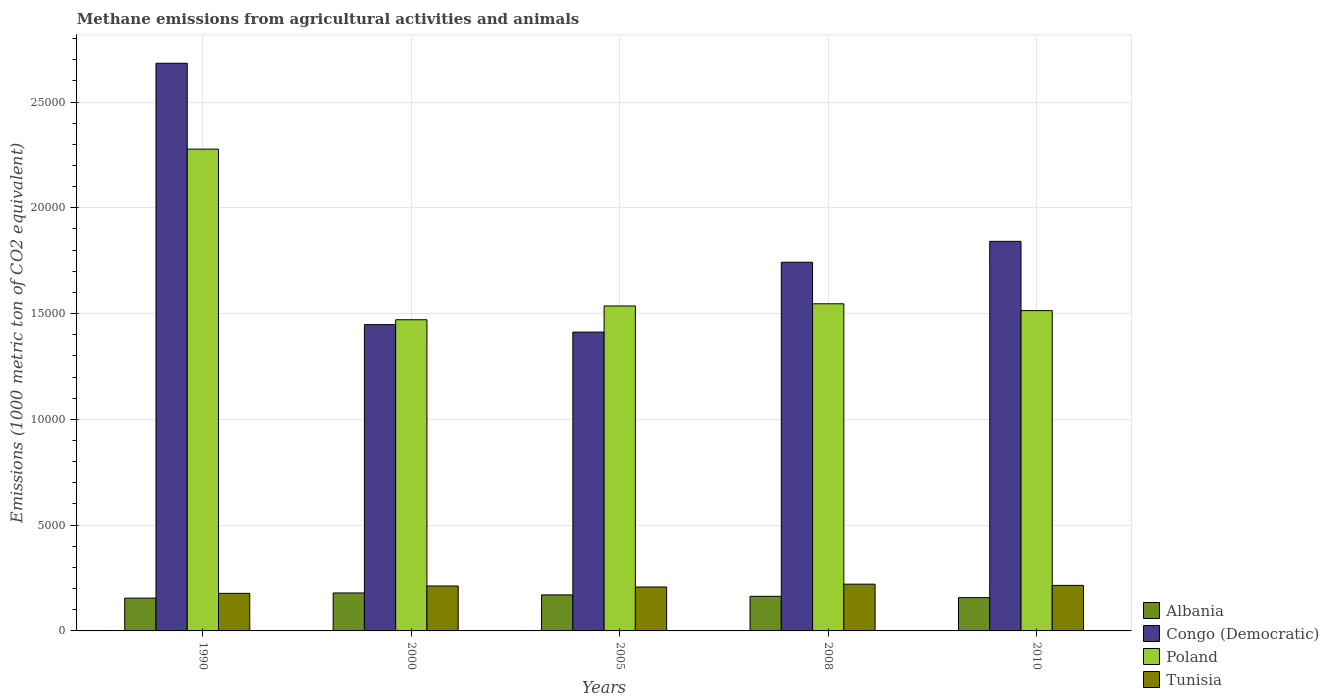How many different coloured bars are there?
Your answer should be very brief. 4. Are the number of bars per tick equal to the number of legend labels?
Your answer should be compact. Yes. Are the number of bars on each tick of the X-axis equal?
Keep it short and to the point. Yes. How many bars are there on the 3rd tick from the left?
Keep it short and to the point. 4. How many bars are there on the 1st tick from the right?
Your response must be concise. 4. In how many cases, is the number of bars for a given year not equal to the number of legend labels?
Keep it short and to the point. 0. What is the amount of methane emitted in Tunisia in 2010?
Your answer should be compact. 2151.9. Across all years, what is the maximum amount of methane emitted in Poland?
Provide a short and direct response. 2.28e+04. Across all years, what is the minimum amount of methane emitted in Tunisia?
Your answer should be very brief. 1775.7. In which year was the amount of methane emitted in Tunisia minimum?
Make the answer very short. 1990. What is the total amount of methane emitted in Poland in the graph?
Offer a very short reply. 8.34e+04. What is the difference between the amount of methane emitted in Albania in 1990 and that in 2000?
Make the answer very short. -243.7. What is the difference between the amount of methane emitted in Congo (Democratic) in 2010 and the amount of methane emitted in Poland in 1990?
Your answer should be very brief. -4358.7. What is the average amount of methane emitted in Poland per year?
Make the answer very short. 1.67e+04. In the year 2000, what is the difference between the amount of methane emitted in Tunisia and amount of methane emitted in Albania?
Your answer should be compact. 329.2. In how many years, is the amount of methane emitted in Tunisia greater than 5000 1000 metric ton?
Your answer should be very brief. 0. What is the ratio of the amount of methane emitted in Tunisia in 2000 to that in 2005?
Your answer should be very brief. 1.02. What is the difference between the highest and the second highest amount of methane emitted in Albania?
Offer a very short reply. 91.7. What is the difference between the highest and the lowest amount of methane emitted in Albania?
Your answer should be very brief. 243.7. Is it the case that in every year, the sum of the amount of methane emitted in Albania and amount of methane emitted in Poland is greater than the sum of amount of methane emitted in Tunisia and amount of methane emitted in Congo (Democratic)?
Make the answer very short. Yes. What does the 4th bar from the right in 2008 represents?
Provide a short and direct response. Albania. How many bars are there?
Ensure brevity in your answer.  20. What is the title of the graph?
Provide a short and direct response. Methane emissions from agricultural activities and animals. What is the label or title of the X-axis?
Ensure brevity in your answer.  Years. What is the label or title of the Y-axis?
Make the answer very short. Emissions (1000 metric ton of CO2 equivalent). What is the Emissions (1000 metric ton of CO2 equivalent) in Albania in 1990?
Ensure brevity in your answer.  1550.9. What is the Emissions (1000 metric ton of CO2 equivalent) in Congo (Democratic) in 1990?
Give a very brief answer. 2.68e+04. What is the Emissions (1000 metric ton of CO2 equivalent) in Poland in 1990?
Make the answer very short. 2.28e+04. What is the Emissions (1000 metric ton of CO2 equivalent) of Tunisia in 1990?
Your response must be concise. 1775.7. What is the Emissions (1000 metric ton of CO2 equivalent) of Albania in 2000?
Ensure brevity in your answer.  1794.6. What is the Emissions (1000 metric ton of CO2 equivalent) of Congo (Democratic) in 2000?
Keep it short and to the point. 1.45e+04. What is the Emissions (1000 metric ton of CO2 equivalent) of Poland in 2000?
Offer a very short reply. 1.47e+04. What is the Emissions (1000 metric ton of CO2 equivalent) in Tunisia in 2000?
Offer a very short reply. 2123.8. What is the Emissions (1000 metric ton of CO2 equivalent) in Albania in 2005?
Keep it short and to the point. 1702.9. What is the Emissions (1000 metric ton of CO2 equivalent) in Congo (Democratic) in 2005?
Make the answer very short. 1.41e+04. What is the Emissions (1000 metric ton of CO2 equivalent) of Poland in 2005?
Offer a terse response. 1.54e+04. What is the Emissions (1000 metric ton of CO2 equivalent) of Tunisia in 2005?
Provide a short and direct response. 2076.8. What is the Emissions (1000 metric ton of CO2 equivalent) in Albania in 2008?
Provide a succinct answer. 1635.8. What is the Emissions (1000 metric ton of CO2 equivalent) of Congo (Democratic) in 2008?
Your answer should be compact. 1.74e+04. What is the Emissions (1000 metric ton of CO2 equivalent) in Poland in 2008?
Your answer should be very brief. 1.55e+04. What is the Emissions (1000 metric ton of CO2 equivalent) of Tunisia in 2008?
Offer a terse response. 2209.8. What is the Emissions (1000 metric ton of CO2 equivalent) in Albania in 2010?
Make the answer very short. 1574.1. What is the Emissions (1000 metric ton of CO2 equivalent) of Congo (Democratic) in 2010?
Your response must be concise. 1.84e+04. What is the Emissions (1000 metric ton of CO2 equivalent) of Poland in 2010?
Your response must be concise. 1.51e+04. What is the Emissions (1000 metric ton of CO2 equivalent) in Tunisia in 2010?
Offer a terse response. 2151.9. Across all years, what is the maximum Emissions (1000 metric ton of CO2 equivalent) of Albania?
Your answer should be compact. 1794.6. Across all years, what is the maximum Emissions (1000 metric ton of CO2 equivalent) in Congo (Democratic)?
Offer a very short reply. 2.68e+04. Across all years, what is the maximum Emissions (1000 metric ton of CO2 equivalent) in Poland?
Keep it short and to the point. 2.28e+04. Across all years, what is the maximum Emissions (1000 metric ton of CO2 equivalent) in Tunisia?
Keep it short and to the point. 2209.8. Across all years, what is the minimum Emissions (1000 metric ton of CO2 equivalent) in Albania?
Give a very brief answer. 1550.9. Across all years, what is the minimum Emissions (1000 metric ton of CO2 equivalent) in Congo (Democratic)?
Make the answer very short. 1.41e+04. Across all years, what is the minimum Emissions (1000 metric ton of CO2 equivalent) in Poland?
Provide a short and direct response. 1.47e+04. Across all years, what is the minimum Emissions (1000 metric ton of CO2 equivalent) of Tunisia?
Your answer should be compact. 1775.7. What is the total Emissions (1000 metric ton of CO2 equivalent) in Albania in the graph?
Your answer should be compact. 8258.3. What is the total Emissions (1000 metric ton of CO2 equivalent) of Congo (Democratic) in the graph?
Give a very brief answer. 9.13e+04. What is the total Emissions (1000 metric ton of CO2 equivalent) of Poland in the graph?
Provide a short and direct response. 8.34e+04. What is the total Emissions (1000 metric ton of CO2 equivalent) in Tunisia in the graph?
Your response must be concise. 1.03e+04. What is the difference between the Emissions (1000 metric ton of CO2 equivalent) of Albania in 1990 and that in 2000?
Make the answer very short. -243.7. What is the difference between the Emissions (1000 metric ton of CO2 equivalent) of Congo (Democratic) in 1990 and that in 2000?
Provide a succinct answer. 1.24e+04. What is the difference between the Emissions (1000 metric ton of CO2 equivalent) of Poland in 1990 and that in 2000?
Give a very brief answer. 8065. What is the difference between the Emissions (1000 metric ton of CO2 equivalent) in Tunisia in 1990 and that in 2000?
Provide a short and direct response. -348.1. What is the difference between the Emissions (1000 metric ton of CO2 equivalent) in Albania in 1990 and that in 2005?
Your answer should be compact. -152. What is the difference between the Emissions (1000 metric ton of CO2 equivalent) of Congo (Democratic) in 1990 and that in 2005?
Keep it short and to the point. 1.27e+04. What is the difference between the Emissions (1000 metric ton of CO2 equivalent) of Poland in 1990 and that in 2005?
Provide a short and direct response. 7413.7. What is the difference between the Emissions (1000 metric ton of CO2 equivalent) in Tunisia in 1990 and that in 2005?
Make the answer very short. -301.1. What is the difference between the Emissions (1000 metric ton of CO2 equivalent) in Albania in 1990 and that in 2008?
Keep it short and to the point. -84.9. What is the difference between the Emissions (1000 metric ton of CO2 equivalent) in Congo (Democratic) in 1990 and that in 2008?
Offer a very short reply. 9404.9. What is the difference between the Emissions (1000 metric ton of CO2 equivalent) in Poland in 1990 and that in 2008?
Keep it short and to the point. 7311.1. What is the difference between the Emissions (1000 metric ton of CO2 equivalent) in Tunisia in 1990 and that in 2008?
Offer a terse response. -434.1. What is the difference between the Emissions (1000 metric ton of CO2 equivalent) in Albania in 1990 and that in 2010?
Your response must be concise. -23.2. What is the difference between the Emissions (1000 metric ton of CO2 equivalent) in Congo (Democratic) in 1990 and that in 2010?
Your answer should be very brief. 8416.9. What is the difference between the Emissions (1000 metric ton of CO2 equivalent) in Poland in 1990 and that in 2010?
Provide a succinct answer. 7634.1. What is the difference between the Emissions (1000 metric ton of CO2 equivalent) in Tunisia in 1990 and that in 2010?
Your answer should be compact. -376.2. What is the difference between the Emissions (1000 metric ton of CO2 equivalent) in Albania in 2000 and that in 2005?
Make the answer very short. 91.7. What is the difference between the Emissions (1000 metric ton of CO2 equivalent) in Congo (Democratic) in 2000 and that in 2005?
Your response must be concise. 352. What is the difference between the Emissions (1000 metric ton of CO2 equivalent) in Poland in 2000 and that in 2005?
Give a very brief answer. -651.3. What is the difference between the Emissions (1000 metric ton of CO2 equivalent) of Albania in 2000 and that in 2008?
Provide a short and direct response. 158.8. What is the difference between the Emissions (1000 metric ton of CO2 equivalent) of Congo (Democratic) in 2000 and that in 2008?
Your response must be concise. -2949. What is the difference between the Emissions (1000 metric ton of CO2 equivalent) in Poland in 2000 and that in 2008?
Keep it short and to the point. -753.9. What is the difference between the Emissions (1000 metric ton of CO2 equivalent) in Tunisia in 2000 and that in 2008?
Provide a succinct answer. -86. What is the difference between the Emissions (1000 metric ton of CO2 equivalent) of Albania in 2000 and that in 2010?
Your answer should be very brief. 220.5. What is the difference between the Emissions (1000 metric ton of CO2 equivalent) of Congo (Democratic) in 2000 and that in 2010?
Offer a terse response. -3937. What is the difference between the Emissions (1000 metric ton of CO2 equivalent) in Poland in 2000 and that in 2010?
Make the answer very short. -430.9. What is the difference between the Emissions (1000 metric ton of CO2 equivalent) of Tunisia in 2000 and that in 2010?
Provide a succinct answer. -28.1. What is the difference between the Emissions (1000 metric ton of CO2 equivalent) in Albania in 2005 and that in 2008?
Provide a succinct answer. 67.1. What is the difference between the Emissions (1000 metric ton of CO2 equivalent) of Congo (Democratic) in 2005 and that in 2008?
Provide a succinct answer. -3301. What is the difference between the Emissions (1000 metric ton of CO2 equivalent) of Poland in 2005 and that in 2008?
Offer a very short reply. -102.6. What is the difference between the Emissions (1000 metric ton of CO2 equivalent) in Tunisia in 2005 and that in 2008?
Provide a short and direct response. -133. What is the difference between the Emissions (1000 metric ton of CO2 equivalent) of Albania in 2005 and that in 2010?
Your answer should be very brief. 128.8. What is the difference between the Emissions (1000 metric ton of CO2 equivalent) of Congo (Democratic) in 2005 and that in 2010?
Make the answer very short. -4289. What is the difference between the Emissions (1000 metric ton of CO2 equivalent) of Poland in 2005 and that in 2010?
Your answer should be compact. 220.4. What is the difference between the Emissions (1000 metric ton of CO2 equivalent) in Tunisia in 2005 and that in 2010?
Your answer should be compact. -75.1. What is the difference between the Emissions (1000 metric ton of CO2 equivalent) of Albania in 2008 and that in 2010?
Offer a terse response. 61.7. What is the difference between the Emissions (1000 metric ton of CO2 equivalent) of Congo (Democratic) in 2008 and that in 2010?
Ensure brevity in your answer.  -988. What is the difference between the Emissions (1000 metric ton of CO2 equivalent) in Poland in 2008 and that in 2010?
Offer a terse response. 323. What is the difference between the Emissions (1000 metric ton of CO2 equivalent) of Tunisia in 2008 and that in 2010?
Your response must be concise. 57.9. What is the difference between the Emissions (1000 metric ton of CO2 equivalent) in Albania in 1990 and the Emissions (1000 metric ton of CO2 equivalent) in Congo (Democratic) in 2000?
Offer a terse response. -1.29e+04. What is the difference between the Emissions (1000 metric ton of CO2 equivalent) of Albania in 1990 and the Emissions (1000 metric ton of CO2 equivalent) of Poland in 2000?
Keep it short and to the point. -1.32e+04. What is the difference between the Emissions (1000 metric ton of CO2 equivalent) of Albania in 1990 and the Emissions (1000 metric ton of CO2 equivalent) of Tunisia in 2000?
Offer a terse response. -572.9. What is the difference between the Emissions (1000 metric ton of CO2 equivalent) in Congo (Democratic) in 1990 and the Emissions (1000 metric ton of CO2 equivalent) in Poland in 2000?
Your answer should be compact. 1.21e+04. What is the difference between the Emissions (1000 metric ton of CO2 equivalent) of Congo (Democratic) in 1990 and the Emissions (1000 metric ton of CO2 equivalent) of Tunisia in 2000?
Your answer should be compact. 2.47e+04. What is the difference between the Emissions (1000 metric ton of CO2 equivalent) of Poland in 1990 and the Emissions (1000 metric ton of CO2 equivalent) of Tunisia in 2000?
Give a very brief answer. 2.06e+04. What is the difference between the Emissions (1000 metric ton of CO2 equivalent) in Albania in 1990 and the Emissions (1000 metric ton of CO2 equivalent) in Congo (Democratic) in 2005?
Give a very brief answer. -1.26e+04. What is the difference between the Emissions (1000 metric ton of CO2 equivalent) of Albania in 1990 and the Emissions (1000 metric ton of CO2 equivalent) of Poland in 2005?
Ensure brevity in your answer.  -1.38e+04. What is the difference between the Emissions (1000 metric ton of CO2 equivalent) in Albania in 1990 and the Emissions (1000 metric ton of CO2 equivalent) in Tunisia in 2005?
Provide a succinct answer. -525.9. What is the difference between the Emissions (1000 metric ton of CO2 equivalent) of Congo (Democratic) in 1990 and the Emissions (1000 metric ton of CO2 equivalent) of Poland in 2005?
Your answer should be compact. 1.15e+04. What is the difference between the Emissions (1000 metric ton of CO2 equivalent) of Congo (Democratic) in 1990 and the Emissions (1000 metric ton of CO2 equivalent) of Tunisia in 2005?
Offer a very short reply. 2.48e+04. What is the difference between the Emissions (1000 metric ton of CO2 equivalent) of Poland in 1990 and the Emissions (1000 metric ton of CO2 equivalent) of Tunisia in 2005?
Your answer should be very brief. 2.07e+04. What is the difference between the Emissions (1000 metric ton of CO2 equivalent) of Albania in 1990 and the Emissions (1000 metric ton of CO2 equivalent) of Congo (Democratic) in 2008?
Provide a short and direct response. -1.59e+04. What is the difference between the Emissions (1000 metric ton of CO2 equivalent) of Albania in 1990 and the Emissions (1000 metric ton of CO2 equivalent) of Poland in 2008?
Offer a terse response. -1.39e+04. What is the difference between the Emissions (1000 metric ton of CO2 equivalent) in Albania in 1990 and the Emissions (1000 metric ton of CO2 equivalent) in Tunisia in 2008?
Your answer should be very brief. -658.9. What is the difference between the Emissions (1000 metric ton of CO2 equivalent) in Congo (Democratic) in 1990 and the Emissions (1000 metric ton of CO2 equivalent) in Poland in 2008?
Your response must be concise. 1.14e+04. What is the difference between the Emissions (1000 metric ton of CO2 equivalent) in Congo (Democratic) in 1990 and the Emissions (1000 metric ton of CO2 equivalent) in Tunisia in 2008?
Offer a very short reply. 2.46e+04. What is the difference between the Emissions (1000 metric ton of CO2 equivalent) of Poland in 1990 and the Emissions (1000 metric ton of CO2 equivalent) of Tunisia in 2008?
Provide a short and direct response. 2.06e+04. What is the difference between the Emissions (1000 metric ton of CO2 equivalent) in Albania in 1990 and the Emissions (1000 metric ton of CO2 equivalent) in Congo (Democratic) in 2010?
Make the answer very short. -1.69e+04. What is the difference between the Emissions (1000 metric ton of CO2 equivalent) in Albania in 1990 and the Emissions (1000 metric ton of CO2 equivalent) in Poland in 2010?
Your response must be concise. -1.36e+04. What is the difference between the Emissions (1000 metric ton of CO2 equivalent) of Albania in 1990 and the Emissions (1000 metric ton of CO2 equivalent) of Tunisia in 2010?
Your answer should be very brief. -601. What is the difference between the Emissions (1000 metric ton of CO2 equivalent) in Congo (Democratic) in 1990 and the Emissions (1000 metric ton of CO2 equivalent) in Poland in 2010?
Give a very brief answer. 1.17e+04. What is the difference between the Emissions (1000 metric ton of CO2 equivalent) of Congo (Democratic) in 1990 and the Emissions (1000 metric ton of CO2 equivalent) of Tunisia in 2010?
Ensure brevity in your answer.  2.47e+04. What is the difference between the Emissions (1000 metric ton of CO2 equivalent) in Poland in 1990 and the Emissions (1000 metric ton of CO2 equivalent) in Tunisia in 2010?
Offer a terse response. 2.06e+04. What is the difference between the Emissions (1000 metric ton of CO2 equivalent) of Albania in 2000 and the Emissions (1000 metric ton of CO2 equivalent) of Congo (Democratic) in 2005?
Your answer should be compact. -1.23e+04. What is the difference between the Emissions (1000 metric ton of CO2 equivalent) of Albania in 2000 and the Emissions (1000 metric ton of CO2 equivalent) of Poland in 2005?
Ensure brevity in your answer.  -1.36e+04. What is the difference between the Emissions (1000 metric ton of CO2 equivalent) of Albania in 2000 and the Emissions (1000 metric ton of CO2 equivalent) of Tunisia in 2005?
Give a very brief answer. -282.2. What is the difference between the Emissions (1000 metric ton of CO2 equivalent) of Congo (Democratic) in 2000 and the Emissions (1000 metric ton of CO2 equivalent) of Poland in 2005?
Give a very brief answer. -882. What is the difference between the Emissions (1000 metric ton of CO2 equivalent) in Congo (Democratic) in 2000 and the Emissions (1000 metric ton of CO2 equivalent) in Tunisia in 2005?
Offer a very short reply. 1.24e+04. What is the difference between the Emissions (1000 metric ton of CO2 equivalent) in Poland in 2000 and the Emissions (1000 metric ton of CO2 equivalent) in Tunisia in 2005?
Offer a terse response. 1.26e+04. What is the difference between the Emissions (1000 metric ton of CO2 equivalent) of Albania in 2000 and the Emissions (1000 metric ton of CO2 equivalent) of Congo (Democratic) in 2008?
Provide a short and direct response. -1.56e+04. What is the difference between the Emissions (1000 metric ton of CO2 equivalent) of Albania in 2000 and the Emissions (1000 metric ton of CO2 equivalent) of Poland in 2008?
Make the answer very short. -1.37e+04. What is the difference between the Emissions (1000 metric ton of CO2 equivalent) in Albania in 2000 and the Emissions (1000 metric ton of CO2 equivalent) in Tunisia in 2008?
Make the answer very short. -415.2. What is the difference between the Emissions (1000 metric ton of CO2 equivalent) of Congo (Democratic) in 2000 and the Emissions (1000 metric ton of CO2 equivalent) of Poland in 2008?
Give a very brief answer. -984.6. What is the difference between the Emissions (1000 metric ton of CO2 equivalent) in Congo (Democratic) in 2000 and the Emissions (1000 metric ton of CO2 equivalent) in Tunisia in 2008?
Offer a very short reply. 1.23e+04. What is the difference between the Emissions (1000 metric ton of CO2 equivalent) in Poland in 2000 and the Emissions (1000 metric ton of CO2 equivalent) in Tunisia in 2008?
Make the answer very short. 1.25e+04. What is the difference between the Emissions (1000 metric ton of CO2 equivalent) in Albania in 2000 and the Emissions (1000 metric ton of CO2 equivalent) in Congo (Democratic) in 2010?
Give a very brief answer. -1.66e+04. What is the difference between the Emissions (1000 metric ton of CO2 equivalent) of Albania in 2000 and the Emissions (1000 metric ton of CO2 equivalent) of Poland in 2010?
Your answer should be compact. -1.33e+04. What is the difference between the Emissions (1000 metric ton of CO2 equivalent) in Albania in 2000 and the Emissions (1000 metric ton of CO2 equivalent) in Tunisia in 2010?
Your answer should be very brief. -357.3. What is the difference between the Emissions (1000 metric ton of CO2 equivalent) in Congo (Democratic) in 2000 and the Emissions (1000 metric ton of CO2 equivalent) in Poland in 2010?
Offer a very short reply. -661.6. What is the difference between the Emissions (1000 metric ton of CO2 equivalent) of Congo (Democratic) in 2000 and the Emissions (1000 metric ton of CO2 equivalent) of Tunisia in 2010?
Keep it short and to the point. 1.23e+04. What is the difference between the Emissions (1000 metric ton of CO2 equivalent) in Poland in 2000 and the Emissions (1000 metric ton of CO2 equivalent) in Tunisia in 2010?
Your answer should be very brief. 1.26e+04. What is the difference between the Emissions (1000 metric ton of CO2 equivalent) in Albania in 2005 and the Emissions (1000 metric ton of CO2 equivalent) in Congo (Democratic) in 2008?
Give a very brief answer. -1.57e+04. What is the difference between the Emissions (1000 metric ton of CO2 equivalent) of Albania in 2005 and the Emissions (1000 metric ton of CO2 equivalent) of Poland in 2008?
Your answer should be very brief. -1.38e+04. What is the difference between the Emissions (1000 metric ton of CO2 equivalent) of Albania in 2005 and the Emissions (1000 metric ton of CO2 equivalent) of Tunisia in 2008?
Provide a short and direct response. -506.9. What is the difference between the Emissions (1000 metric ton of CO2 equivalent) of Congo (Democratic) in 2005 and the Emissions (1000 metric ton of CO2 equivalent) of Poland in 2008?
Offer a terse response. -1336.6. What is the difference between the Emissions (1000 metric ton of CO2 equivalent) in Congo (Democratic) in 2005 and the Emissions (1000 metric ton of CO2 equivalent) in Tunisia in 2008?
Your response must be concise. 1.19e+04. What is the difference between the Emissions (1000 metric ton of CO2 equivalent) of Poland in 2005 and the Emissions (1000 metric ton of CO2 equivalent) of Tunisia in 2008?
Ensure brevity in your answer.  1.32e+04. What is the difference between the Emissions (1000 metric ton of CO2 equivalent) of Albania in 2005 and the Emissions (1000 metric ton of CO2 equivalent) of Congo (Democratic) in 2010?
Ensure brevity in your answer.  -1.67e+04. What is the difference between the Emissions (1000 metric ton of CO2 equivalent) in Albania in 2005 and the Emissions (1000 metric ton of CO2 equivalent) in Poland in 2010?
Your response must be concise. -1.34e+04. What is the difference between the Emissions (1000 metric ton of CO2 equivalent) in Albania in 2005 and the Emissions (1000 metric ton of CO2 equivalent) in Tunisia in 2010?
Ensure brevity in your answer.  -449. What is the difference between the Emissions (1000 metric ton of CO2 equivalent) of Congo (Democratic) in 2005 and the Emissions (1000 metric ton of CO2 equivalent) of Poland in 2010?
Your response must be concise. -1013.6. What is the difference between the Emissions (1000 metric ton of CO2 equivalent) of Congo (Democratic) in 2005 and the Emissions (1000 metric ton of CO2 equivalent) of Tunisia in 2010?
Make the answer very short. 1.20e+04. What is the difference between the Emissions (1000 metric ton of CO2 equivalent) of Poland in 2005 and the Emissions (1000 metric ton of CO2 equivalent) of Tunisia in 2010?
Give a very brief answer. 1.32e+04. What is the difference between the Emissions (1000 metric ton of CO2 equivalent) of Albania in 2008 and the Emissions (1000 metric ton of CO2 equivalent) of Congo (Democratic) in 2010?
Ensure brevity in your answer.  -1.68e+04. What is the difference between the Emissions (1000 metric ton of CO2 equivalent) in Albania in 2008 and the Emissions (1000 metric ton of CO2 equivalent) in Poland in 2010?
Your answer should be compact. -1.35e+04. What is the difference between the Emissions (1000 metric ton of CO2 equivalent) in Albania in 2008 and the Emissions (1000 metric ton of CO2 equivalent) in Tunisia in 2010?
Ensure brevity in your answer.  -516.1. What is the difference between the Emissions (1000 metric ton of CO2 equivalent) in Congo (Democratic) in 2008 and the Emissions (1000 metric ton of CO2 equivalent) in Poland in 2010?
Your response must be concise. 2287.4. What is the difference between the Emissions (1000 metric ton of CO2 equivalent) in Congo (Democratic) in 2008 and the Emissions (1000 metric ton of CO2 equivalent) in Tunisia in 2010?
Offer a very short reply. 1.53e+04. What is the difference between the Emissions (1000 metric ton of CO2 equivalent) in Poland in 2008 and the Emissions (1000 metric ton of CO2 equivalent) in Tunisia in 2010?
Your answer should be compact. 1.33e+04. What is the average Emissions (1000 metric ton of CO2 equivalent) in Albania per year?
Your answer should be very brief. 1651.66. What is the average Emissions (1000 metric ton of CO2 equivalent) of Congo (Democratic) per year?
Ensure brevity in your answer.  1.83e+04. What is the average Emissions (1000 metric ton of CO2 equivalent) of Poland per year?
Provide a succinct answer. 1.67e+04. What is the average Emissions (1000 metric ton of CO2 equivalent) of Tunisia per year?
Your response must be concise. 2067.6. In the year 1990, what is the difference between the Emissions (1000 metric ton of CO2 equivalent) in Albania and Emissions (1000 metric ton of CO2 equivalent) in Congo (Democratic)?
Provide a succinct answer. -2.53e+04. In the year 1990, what is the difference between the Emissions (1000 metric ton of CO2 equivalent) in Albania and Emissions (1000 metric ton of CO2 equivalent) in Poland?
Provide a succinct answer. -2.12e+04. In the year 1990, what is the difference between the Emissions (1000 metric ton of CO2 equivalent) in Albania and Emissions (1000 metric ton of CO2 equivalent) in Tunisia?
Make the answer very short. -224.8. In the year 1990, what is the difference between the Emissions (1000 metric ton of CO2 equivalent) in Congo (Democratic) and Emissions (1000 metric ton of CO2 equivalent) in Poland?
Ensure brevity in your answer.  4058.2. In the year 1990, what is the difference between the Emissions (1000 metric ton of CO2 equivalent) in Congo (Democratic) and Emissions (1000 metric ton of CO2 equivalent) in Tunisia?
Keep it short and to the point. 2.51e+04. In the year 1990, what is the difference between the Emissions (1000 metric ton of CO2 equivalent) in Poland and Emissions (1000 metric ton of CO2 equivalent) in Tunisia?
Provide a short and direct response. 2.10e+04. In the year 2000, what is the difference between the Emissions (1000 metric ton of CO2 equivalent) in Albania and Emissions (1000 metric ton of CO2 equivalent) in Congo (Democratic)?
Offer a very short reply. -1.27e+04. In the year 2000, what is the difference between the Emissions (1000 metric ton of CO2 equivalent) of Albania and Emissions (1000 metric ton of CO2 equivalent) of Poland?
Your answer should be compact. -1.29e+04. In the year 2000, what is the difference between the Emissions (1000 metric ton of CO2 equivalent) of Albania and Emissions (1000 metric ton of CO2 equivalent) of Tunisia?
Offer a terse response. -329.2. In the year 2000, what is the difference between the Emissions (1000 metric ton of CO2 equivalent) in Congo (Democratic) and Emissions (1000 metric ton of CO2 equivalent) in Poland?
Your answer should be compact. -230.7. In the year 2000, what is the difference between the Emissions (1000 metric ton of CO2 equivalent) in Congo (Democratic) and Emissions (1000 metric ton of CO2 equivalent) in Tunisia?
Your answer should be very brief. 1.24e+04. In the year 2000, what is the difference between the Emissions (1000 metric ton of CO2 equivalent) in Poland and Emissions (1000 metric ton of CO2 equivalent) in Tunisia?
Your answer should be very brief. 1.26e+04. In the year 2005, what is the difference between the Emissions (1000 metric ton of CO2 equivalent) of Albania and Emissions (1000 metric ton of CO2 equivalent) of Congo (Democratic)?
Your answer should be very brief. -1.24e+04. In the year 2005, what is the difference between the Emissions (1000 metric ton of CO2 equivalent) of Albania and Emissions (1000 metric ton of CO2 equivalent) of Poland?
Make the answer very short. -1.37e+04. In the year 2005, what is the difference between the Emissions (1000 metric ton of CO2 equivalent) of Albania and Emissions (1000 metric ton of CO2 equivalent) of Tunisia?
Provide a succinct answer. -373.9. In the year 2005, what is the difference between the Emissions (1000 metric ton of CO2 equivalent) in Congo (Democratic) and Emissions (1000 metric ton of CO2 equivalent) in Poland?
Make the answer very short. -1234. In the year 2005, what is the difference between the Emissions (1000 metric ton of CO2 equivalent) of Congo (Democratic) and Emissions (1000 metric ton of CO2 equivalent) of Tunisia?
Ensure brevity in your answer.  1.20e+04. In the year 2005, what is the difference between the Emissions (1000 metric ton of CO2 equivalent) of Poland and Emissions (1000 metric ton of CO2 equivalent) of Tunisia?
Your answer should be compact. 1.33e+04. In the year 2008, what is the difference between the Emissions (1000 metric ton of CO2 equivalent) in Albania and Emissions (1000 metric ton of CO2 equivalent) in Congo (Democratic)?
Offer a terse response. -1.58e+04. In the year 2008, what is the difference between the Emissions (1000 metric ton of CO2 equivalent) in Albania and Emissions (1000 metric ton of CO2 equivalent) in Poland?
Offer a very short reply. -1.38e+04. In the year 2008, what is the difference between the Emissions (1000 metric ton of CO2 equivalent) in Albania and Emissions (1000 metric ton of CO2 equivalent) in Tunisia?
Keep it short and to the point. -574. In the year 2008, what is the difference between the Emissions (1000 metric ton of CO2 equivalent) of Congo (Democratic) and Emissions (1000 metric ton of CO2 equivalent) of Poland?
Give a very brief answer. 1964.4. In the year 2008, what is the difference between the Emissions (1000 metric ton of CO2 equivalent) of Congo (Democratic) and Emissions (1000 metric ton of CO2 equivalent) of Tunisia?
Keep it short and to the point. 1.52e+04. In the year 2008, what is the difference between the Emissions (1000 metric ton of CO2 equivalent) of Poland and Emissions (1000 metric ton of CO2 equivalent) of Tunisia?
Provide a short and direct response. 1.33e+04. In the year 2010, what is the difference between the Emissions (1000 metric ton of CO2 equivalent) of Albania and Emissions (1000 metric ton of CO2 equivalent) of Congo (Democratic)?
Give a very brief answer. -1.68e+04. In the year 2010, what is the difference between the Emissions (1000 metric ton of CO2 equivalent) in Albania and Emissions (1000 metric ton of CO2 equivalent) in Poland?
Give a very brief answer. -1.36e+04. In the year 2010, what is the difference between the Emissions (1000 metric ton of CO2 equivalent) in Albania and Emissions (1000 metric ton of CO2 equivalent) in Tunisia?
Keep it short and to the point. -577.8. In the year 2010, what is the difference between the Emissions (1000 metric ton of CO2 equivalent) in Congo (Democratic) and Emissions (1000 metric ton of CO2 equivalent) in Poland?
Offer a terse response. 3275.4. In the year 2010, what is the difference between the Emissions (1000 metric ton of CO2 equivalent) in Congo (Democratic) and Emissions (1000 metric ton of CO2 equivalent) in Tunisia?
Provide a short and direct response. 1.63e+04. In the year 2010, what is the difference between the Emissions (1000 metric ton of CO2 equivalent) in Poland and Emissions (1000 metric ton of CO2 equivalent) in Tunisia?
Your answer should be compact. 1.30e+04. What is the ratio of the Emissions (1000 metric ton of CO2 equivalent) of Albania in 1990 to that in 2000?
Make the answer very short. 0.86. What is the ratio of the Emissions (1000 metric ton of CO2 equivalent) of Congo (Democratic) in 1990 to that in 2000?
Give a very brief answer. 1.85. What is the ratio of the Emissions (1000 metric ton of CO2 equivalent) of Poland in 1990 to that in 2000?
Provide a succinct answer. 1.55. What is the ratio of the Emissions (1000 metric ton of CO2 equivalent) of Tunisia in 1990 to that in 2000?
Your answer should be very brief. 0.84. What is the ratio of the Emissions (1000 metric ton of CO2 equivalent) in Albania in 1990 to that in 2005?
Your answer should be very brief. 0.91. What is the ratio of the Emissions (1000 metric ton of CO2 equivalent) in Congo (Democratic) in 1990 to that in 2005?
Offer a very short reply. 1.9. What is the ratio of the Emissions (1000 metric ton of CO2 equivalent) of Poland in 1990 to that in 2005?
Give a very brief answer. 1.48. What is the ratio of the Emissions (1000 metric ton of CO2 equivalent) in Tunisia in 1990 to that in 2005?
Ensure brevity in your answer.  0.85. What is the ratio of the Emissions (1000 metric ton of CO2 equivalent) of Albania in 1990 to that in 2008?
Give a very brief answer. 0.95. What is the ratio of the Emissions (1000 metric ton of CO2 equivalent) of Congo (Democratic) in 1990 to that in 2008?
Give a very brief answer. 1.54. What is the ratio of the Emissions (1000 metric ton of CO2 equivalent) of Poland in 1990 to that in 2008?
Give a very brief answer. 1.47. What is the ratio of the Emissions (1000 metric ton of CO2 equivalent) of Tunisia in 1990 to that in 2008?
Your answer should be compact. 0.8. What is the ratio of the Emissions (1000 metric ton of CO2 equivalent) in Albania in 1990 to that in 2010?
Offer a terse response. 0.99. What is the ratio of the Emissions (1000 metric ton of CO2 equivalent) in Congo (Democratic) in 1990 to that in 2010?
Ensure brevity in your answer.  1.46. What is the ratio of the Emissions (1000 metric ton of CO2 equivalent) in Poland in 1990 to that in 2010?
Give a very brief answer. 1.5. What is the ratio of the Emissions (1000 metric ton of CO2 equivalent) in Tunisia in 1990 to that in 2010?
Your answer should be compact. 0.83. What is the ratio of the Emissions (1000 metric ton of CO2 equivalent) of Albania in 2000 to that in 2005?
Your answer should be compact. 1.05. What is the ratio of the Emissions (1000 metric ton of CO2 equivalent) of Congo (Democratic) in 2000 to that in 2005?
Give a very brief answer. 1.02. What is the ratio of the Emissions (1000 metric ton of CO2 equivalent) of Poland in 2000 to that in 2005?
Your response must be concise. 0.96. What is the ratio of the Emissions (1000 metric ton of CO2 equivalent) in Tunisia in 2000 to that in 2005?
Offer a very short reply. 1.02. What is the ratio of the Emissions (1000 metric ton of CO2 equivalent) in Albania in 2000 to that in 2008?
Provide a short and direct response. 1.1. What is the ratio of the Emissions (1000 metric ton of CO2 equivalent) in Congo (Democratic) in 2000 to that in 2008?
Make the answer very short. 0.83. What is the ratio of the Emissions (1000 metric ton of CO2 equivalent) of Poland in 2000 to that in 2008?
Your answer should be compact. 0.95. What is the ratio of the Emissions (1000 metric ton of CO2 equivalent) of Tunisia in 2000 to that in 2008?
Your answer should be compact. 0.96. What is the ratio of the Emissions (1000 metric ton of CO2 equivalent) of Albania in 2000 to that in 2010?
Your answer should be very brief. 1.14. What is the ratio of the Emissions (1000 metric ton of CO2 equivalent) of Congo (Democratic) in 2000 to that in 2010?
Ensure brevity in your answer.  0.79. What is the ratio of the Emissions (1000 metric ton of CO2 equivalent) of Poland in 2000 to that in 2010?
Keep it short and to the point. 0.97. What is the ratio of the Emissions (1000 metric ton of CO2 equivalent) in Tunisia in 2000 to that in 2010?
Provide a succinct answer. 0.99. What is the ratio of the Emissions (1000 metric ton of CO2 equivalent) in Albania in 2005 to that in 2008?
Your response must be concise. 1.04. What is the ratio of the Emissions (1000 metric ton of CO2 equivalent) of Congo (Democratic) in 2005 to that in 2008?
Provide a short and direct response. 0.81. What is the ratio of the Emissions (1000 metric ton of CO2 equivalent) of Tunisia in 2005 to that in 2008?
Your response must be concise. 0.94. What is the ratio of the Emissions (1000 metric ton of CO2 equivalent) in Albania in 2005 to that in 2010?
Offer a terse response. 1.08. What is the ratio of the Emissions (1000 metric ton of CO2 equivalent) of Congo (Democratic) in 2005 to that in 2010?
Your answer should be very brief. 0.77. What is the ratio of the Emissions (1000 metric ton of CO2 equivalent) in Poland in 2005 to that in 2010?
Your answer should be compact. 1.01. What is the ratio of the Emissions (1000 metric ton of CO2 equivalent) in Tunisia in 2005 to that in 2010?
Your response must be concise. 0.97. What is the ratio of the Emissions (1000 metric ton of CO2 equivalent) of Albania in 2008 to that in 2010?
Keep it short and to the point. 1.04. What is the ratio of the Emissions (1000 metric ton of CO2 equivalent) of Congo (Democratic) in 2008 to that in 2010?
Your answer should be compact. 0.95. What is the ratio of the Emissions (1000 metric ton of CO2 equivalent) in Poland in 2008 to that in 2010?
Your response must be concise. 1.02. What is the ratio of the Emissions (1000 metric ton of CO2 equivalent) in Tunisia in 2008 to that in 2010?
Make the answer very short. 1.03. What is the difference between the highest and the second highest Emissions (1000 metric ton of CO2 equivalent) in Albania?
Provide a short and direct response. 91.7. What is the difference between the highest and the second highest Emissions (1000 metric ton of CO2 equivalent) in Congo (Democratic)?
Keep it short and to the point. 8416.9. What is the difference between the highest and the second highest Emissions (1000 metric ton of CO2 equivalent) of Poland?
Your answer should be very brief. 7311.1. What is the difference between the highest and the second highest Emissions (1000 metric ton of CO2 equivalent) of Tunisia?
Your answer should be very brief. 57.9. What is the difference between the highest and the lowest Emissions (1000 metric ton of CO2 equivalent) in Albania?
Offer a very short reply. 243.7. What is the difference between the highest and the lowest Emissions (1000 metric ton of CO2 equivalent) in Congo (Democratic)?
Your response must be concise. 1.27e+04. What is the difference between the highest and the lowest Emissions (1000 metric ton of CO2 equivalent) in Poland?
Your response must be concise. 8065. What is the difference between the highest and the lowest Emissions (1000 metric ton of CO2 equivalent) of Tunisia?
Offer a very short reply. 434.1. 